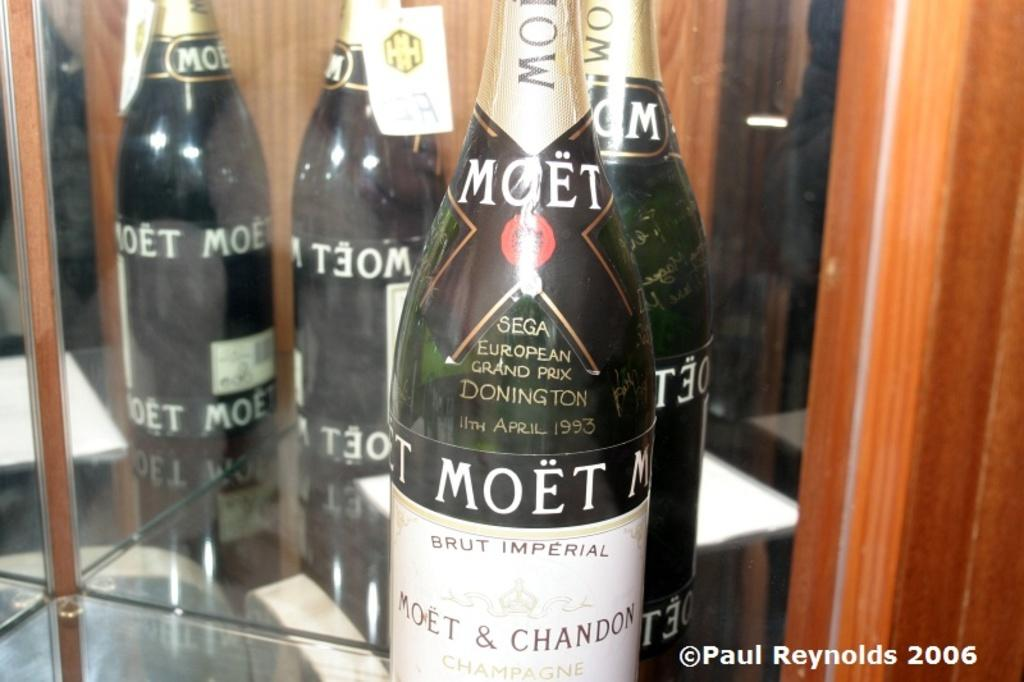<image>
Summarize the visual content of the image. the name Paul Reynolds is on the bottle of alcohol 